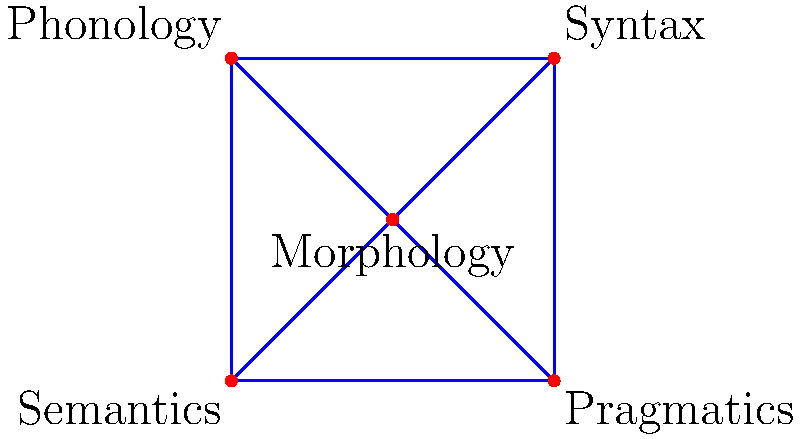In the given knowledge graph of linguistic terms, which concept has the highest degree centrality? To determine the concept with the highest degree centrality, we need to follow these steps:

1. Understand degree centrality: Degree centrality is a measure of the number of direct connections a node has in a graph.

2. Count the connections for each concept:
   - Morphology: 4 connections (to Syntax, Phonology, Semantics, and Pragmatics)
   - Syntax: 3 connections (to Morphology, Phonology, and Pragmatics)
   - Phonology: 3 connections (to Morphology, Syntax, and Semantics)
   - Semantics: 3 connections (to Morphology, Phonology, and Pragmatics)
   - Pragmatics: 3 connections (to Morphology, Syntax, and Semantics)

3. Compare the number of connections:
   Morphology has the highest number of connections with 4, while all other concepts have 3 connections each.

4. Conclusion: Morphology has the highest degree centrality in this knowledge graph of linguistic terms.

This result indicates that Morphology is the most connected concept in this representation of linguistic terms, suggesting its central role in relating different areas of linguistics.
Answer: Morphology 